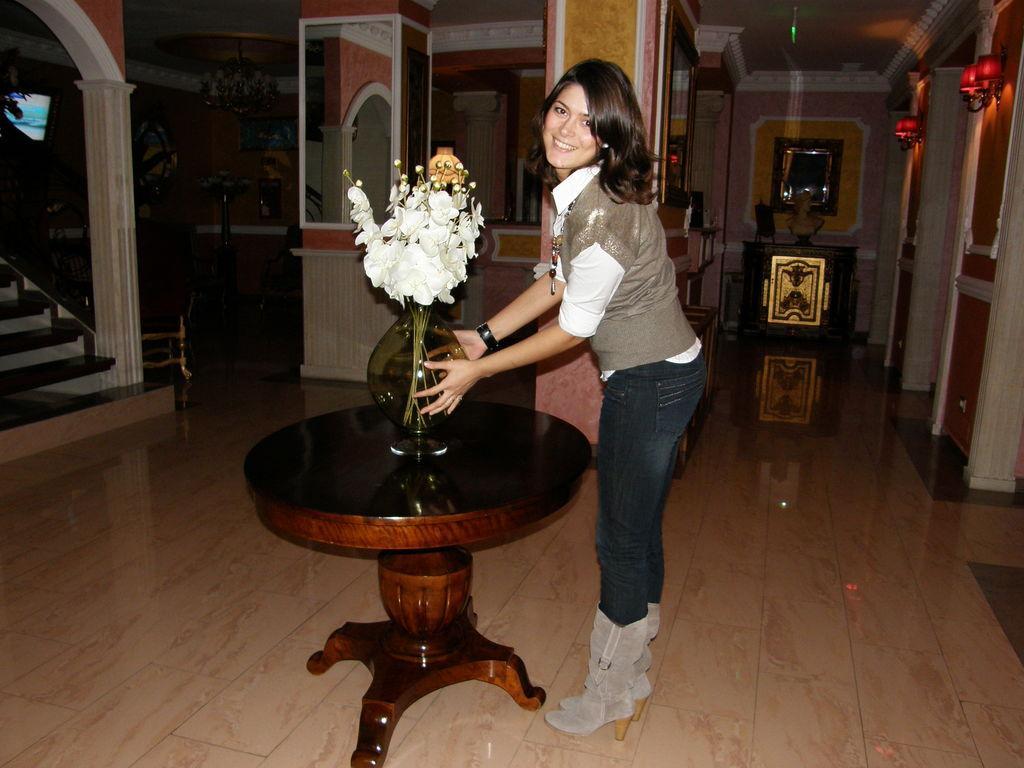Please provide a concise description of this image. In this image I can see a woman is holding the flower vase, she wore coat, shirt, trouser, shoes. On the left side there is a staircase, on the right side there are lights to the wall. 